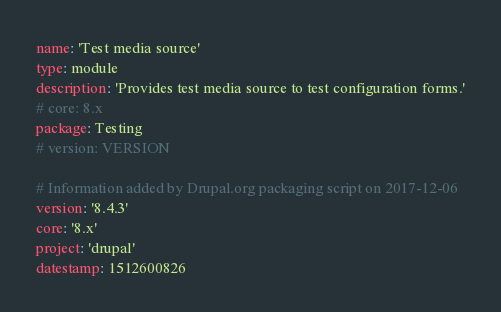Convert code to text. <code><loc_0><loc_0><loc_500><loc_500><_YAML_>name: 'Test media source'
type: module
description: 'Provides test media source to test configuration forms.'
# core: 8.x
package: Testing
# version: VERSION

# Information added by Drupal.org packaging script on 2017-12-06
version: '8.4.3'
core: '8.x'
project: 'drupal'
datestamp: 1512600826
</code> 